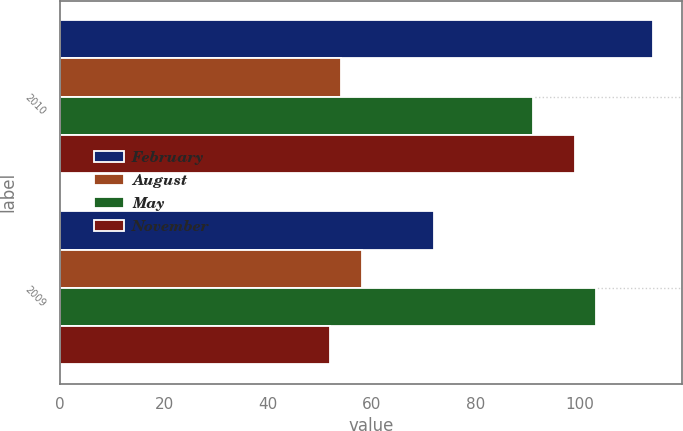<chart> <loc_0><loc_0><loc_500><loc_500><stacked_bar_chart><ecel><fcel>2010<fcel>2009<nl><fcel>February<fcel>114<fcel>72<nl><fcel>August<fcel>54<fcel>58<nl><fcel>May<fcel>91<fcel>103<nl><fcel>November<fcel>99<fcel>52<nl></chart> 